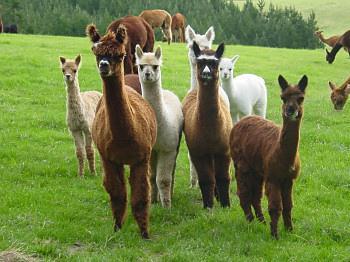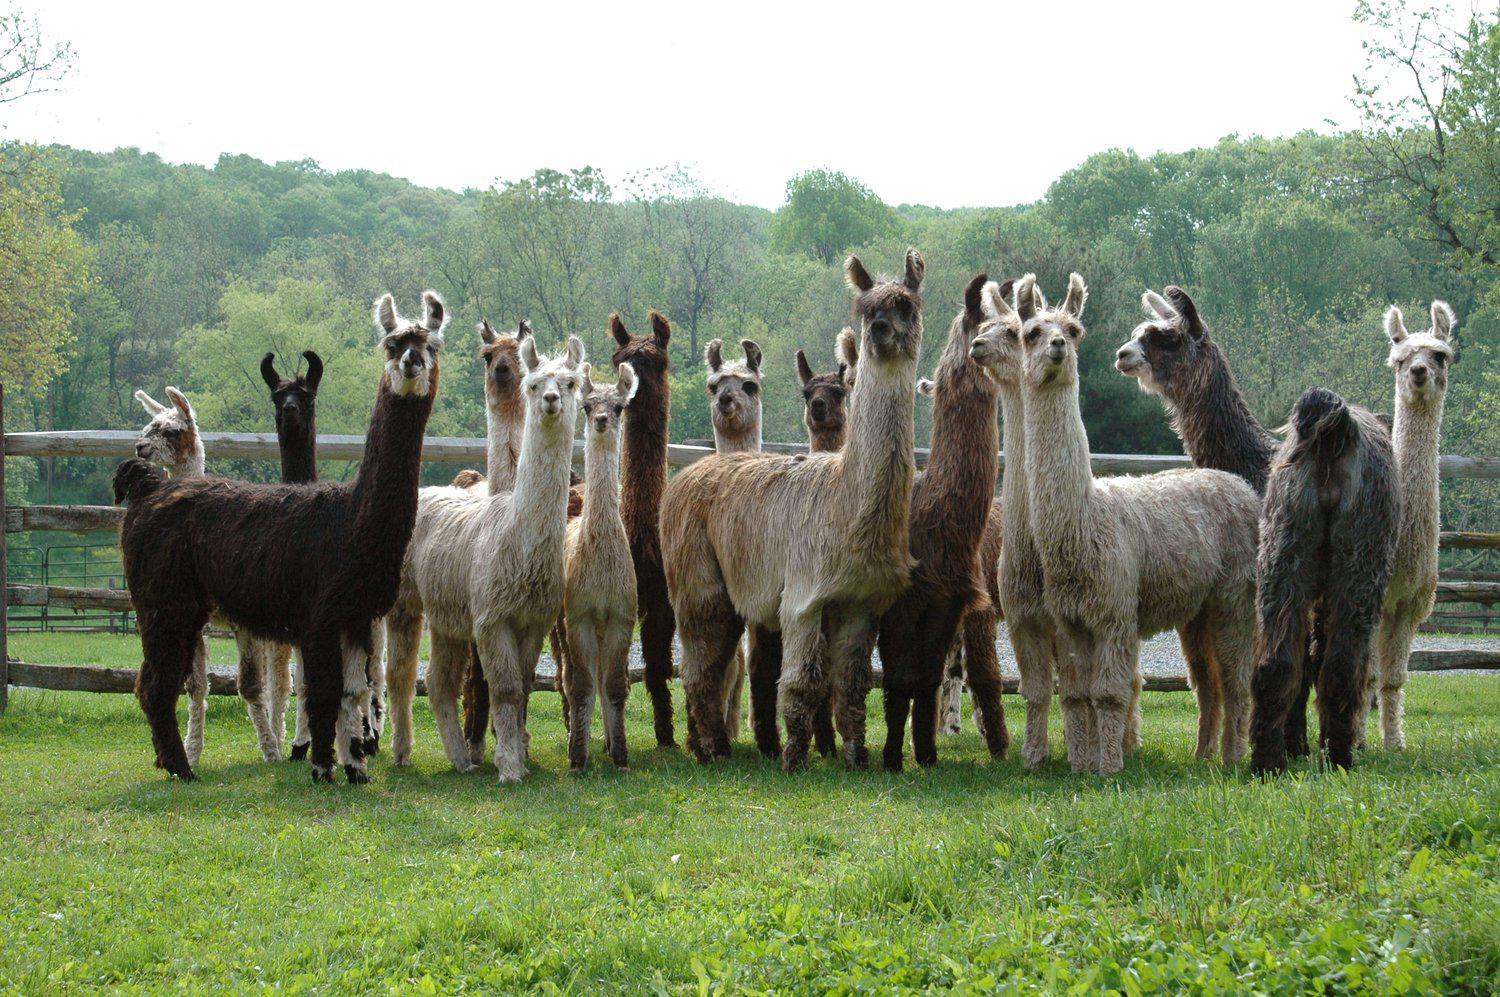The first image is the image on the left, the second image is the image on the right. Assess this claim about the two images: "In the image to the right, there are fewer than ten llamas.". Correct or not? Answer yes or no. No. The first image is the image on the left, the second image is the image on the right. Considering the images on both sides, is "Each image includes at least four llamas, and no image shows a group of forward-facing llamas." valid? Answer yes or no. No. 